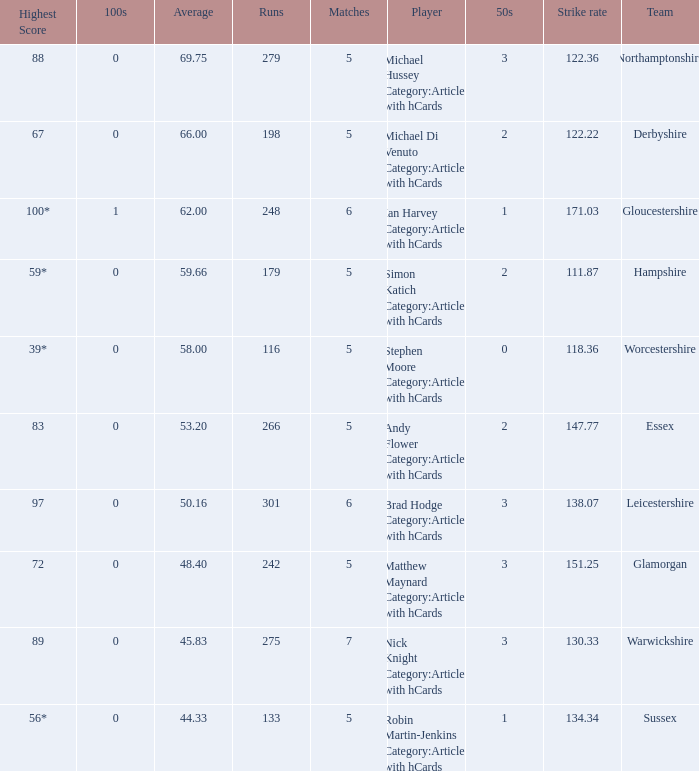If the highest score is 88, what are the 50s? 3.0. 